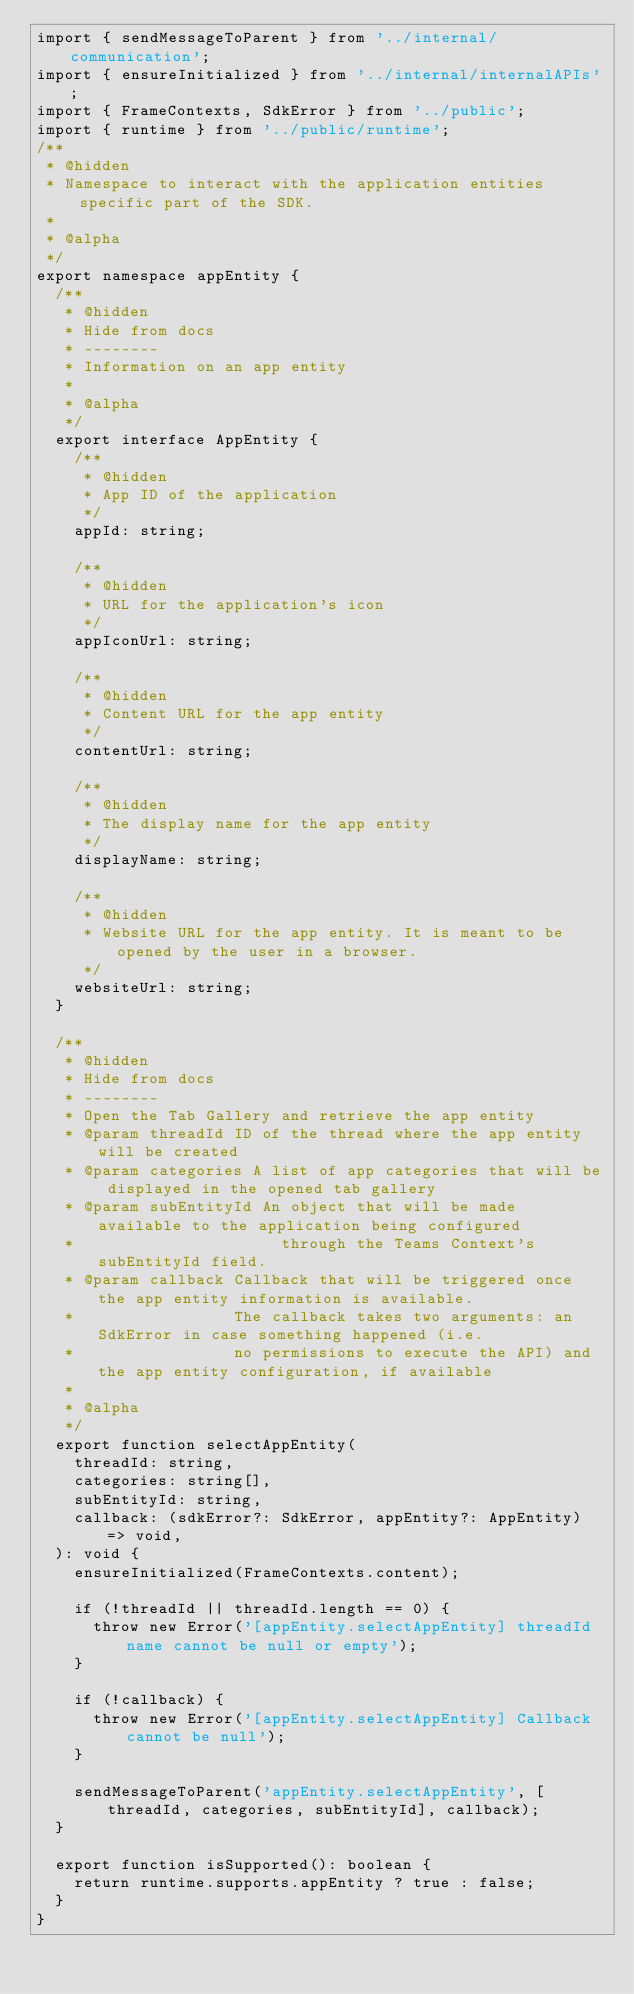Convert code to text. <code><loc_0><loc_0><loc_500><loc_500><_TypeScript_>import { sendMessageToParent } from '../internal/communication';
import { ensureInitialized } from '../internal/internalAPIs';
import { FrameContexts, SdkError } from '../public';
import { runtime } from '../public/runtime';
/**
 * @hidden
 * Namespace to interact with the application entities specific part of the SDK.
 *
 * @alpha
 */
export namespace appEntity {
  /**
   * @hidden
   * Hide from docs
   * --------
   * Information on an app entity
   *
   * @alpha
   */
  export interface AppEntity {
    /**
     * @hidden
     * App ID of the application
     */
    appId: string;

    /**
     * @hidden
     * URL for the application's icon
     */
    appIconUrl: string;

    /**
     * @hidden
     * Content URL for the app entity
     */
    contentUrl: string;

    /**
     * @hidden
     * The display name for the app entity
     */
    displayName: string;

    /**
     * @hidden
     * Website URL for the app entity. It is meant to be opened by the user in a browser.
     */
    websiteUrl: string;
  }

  /**
   * @hidden
   * Hide from docs
   * --------
   * Open the Tab Gallery and retrieve the app entity
   * @param threadId ID of the thread where the app entity will be created
   * @param categories A list of app categories that will be displayed in the opened tab gallery
   * @param subEntityId An object that will be made available to the application being configured
   *                      through the Teams Context's subEntityId field.
   * @param callback Callback that will be triggered once the app entity information is available.
   *                 The callback takes two arguments: an SdkError in case something happened (i.e.
   *                 no permissions to execute the API) and the app entity configuration, if available
   *
   * @alpha
   */
  export function selectAppEntity(
    threadId: string,
    categories: string[],
    subEntityId: string,
    callback: (sdkError?: SdkError, appEntity?: AppEntity) => void,
  ): void {
    ensureInitialized(FrameContexts.content);

    if (!threadId || threadId.length == 0) {
      throw new Error('[appEntity.selectAppEntity] threadId name cannot be null or empty');
    }

    if (!callback) {
      throw new Error('[appEntity.selectAppEntity] Callback cannot be null');
    }

    sendMessageToParent('appEntity.selectAppEntity', [threadId, categories, subEntityId], callback);
  }

  export function isSupported(): boolean {
    return runtime.supports.appEntity ? true : false;
  }
}
</code> 